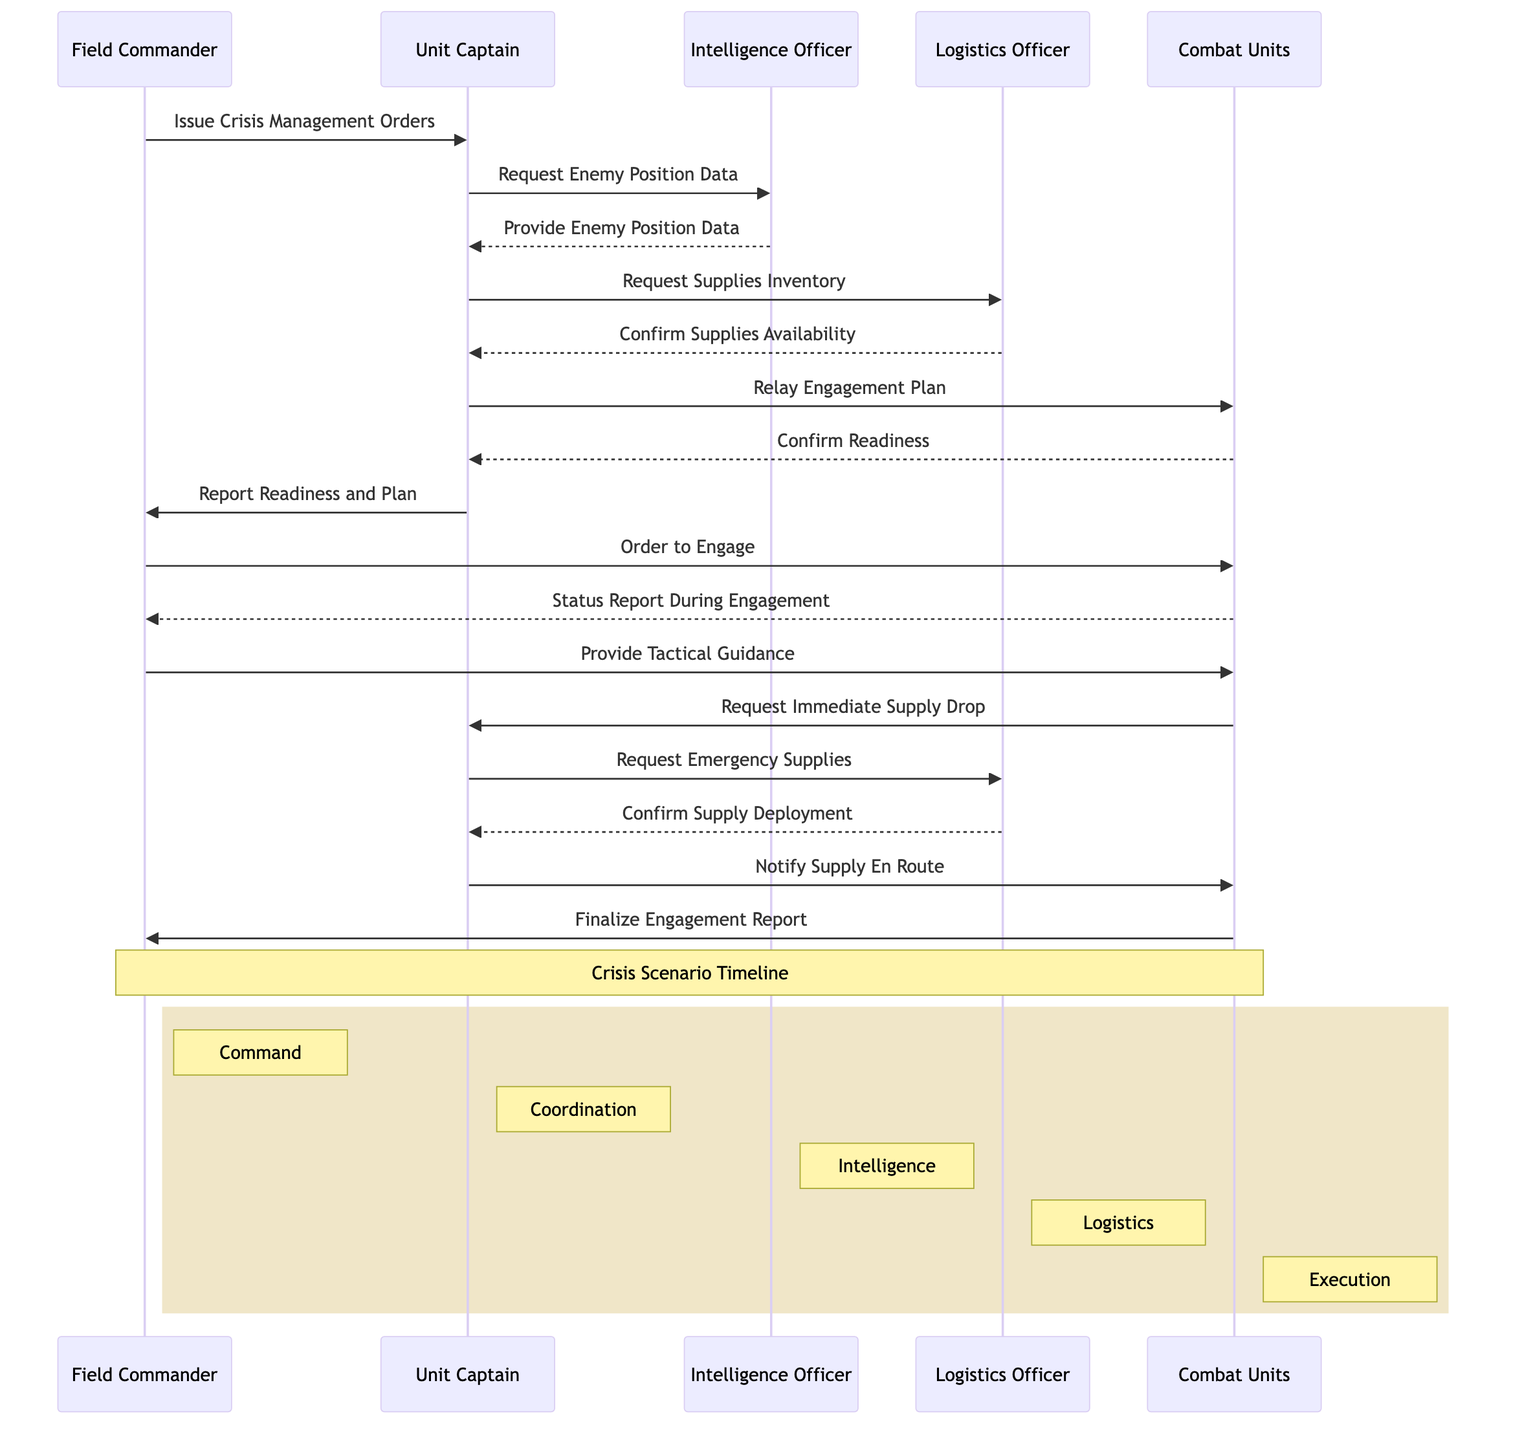What is the first message sent in the sequence? The first message sent is from the Field Commander to the Unit Captain, which is labeled as "Issue Crisis Management Orders." This establishes the initial command in the crisis management process.
Answer: Issue Crisis Management Orders How many lifelines are included in the diagram? The diagram includes five lifelines: Field Commander, Unit Captain, Intelligence Officer, Logistics Officer, and Combat Units. This shows the various roles involved in the crisis scenario.
Answer: 5 Who does the Unit Captain request enemy position data from? The Unit Captain requests enemy position data from the Intelligence Officer, highlighting the communication necessary to gather information about enemy movements.
Answer: Intelligence Officer What action does the Field Commander take after receiving the report from the Unit Captain? After the Unit Captain reports readiness and the engagement plan, the Field Commander issues an order to engage the Combat Units, thereby giving the authorization to proceed with the engagement.
Answer: Order to Engage What is the purpose of the message "Request Emergency Supplies"? The message "Request Emergency Supplies" is a communication from the Unit Captain to the Logistics Officer, indicating that the Combat Units require urgent supplies during an engagement scenario. This highlights the need for prompt logistical support in crisis situations.
Answer: Request Emergency Supplies How many messages are exchanged between the Unit Captain and the Logistics Officer? There are three messages exchanged between the Unit Captain and the Logistics Officer: a request for supplies inventory, a request for emergency supplies, and a confirmation of supply deployment. This illustrates the crucial logistical communication during the crisis.
Answer: 3 What does the Combat Units' status report indicate during the engagement? The Combat Units provide a status report during the engagement to the Field Commander, which includes updates on their current situation, effectiveness, and any issues arising while engaging with the enemy.
Answer: Status Report During Engagement What is the final message communicated in the sequence? The final message communicated in the sequence is "Finalize Engagement Report" from the Combat Units to the Field Commander, summarizing the outcomes and details of the engagement after operations have concluded.
Answer: Finalize Engagement Report 